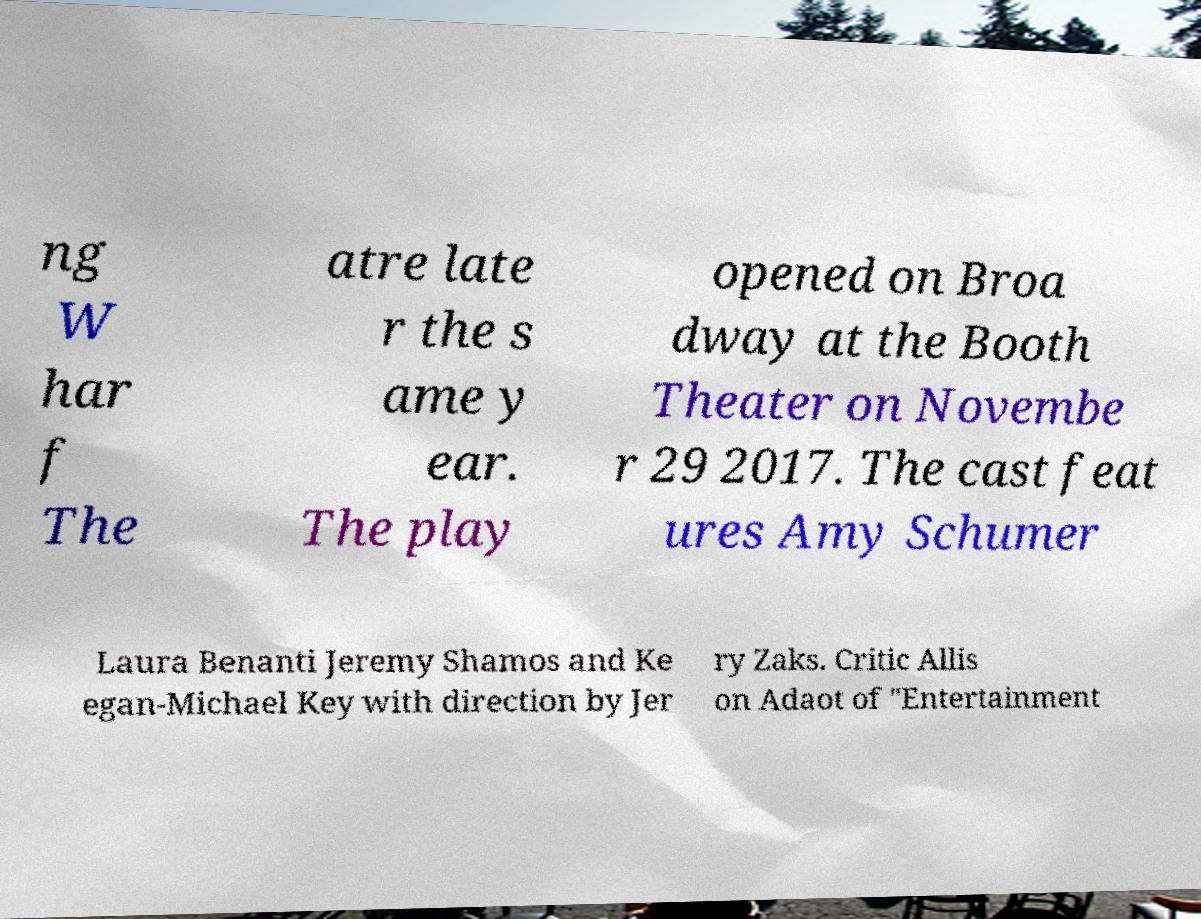What messages or text are displayed in this image? I need them in a readable, typed format. ng W har f The atre late r the s ame y ear. The play opened on Broa dway at the Booth Theater on Novembe r 29 2017. The cast feat ures Amy Schumer Laura Benanti Jeremy Shamos and Ke egan-Michael Key with direction by Jer ry Zaks. Critic Allis on Adaot of "Entertainment 